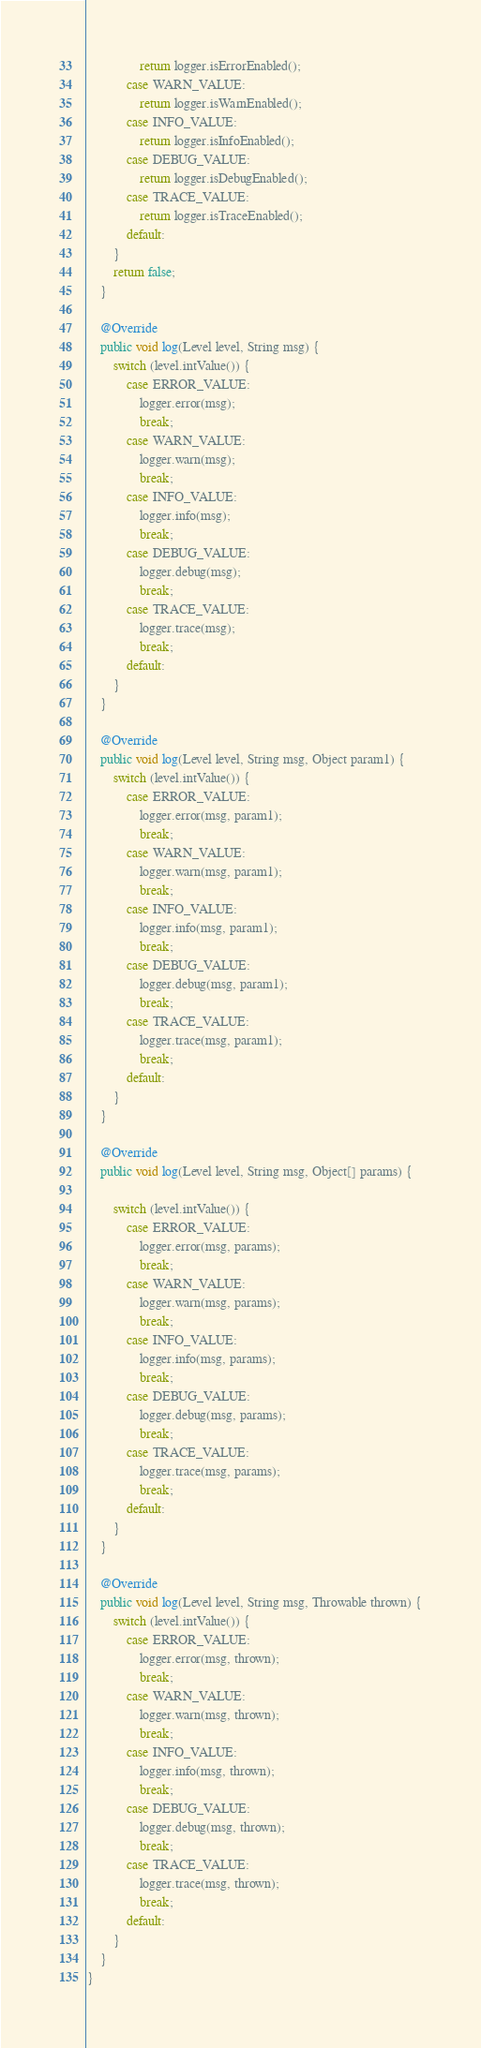<code> <loc_0><loc_0><loc_500><loc_500><_Java_>                return logger.isErrorEnabled();
            case WARN_VALUE:
                return logger.isWarnEnabled();
            case INFO_VALUE:
                return logger.isInfoEnabled();
            case DEBUG_VALUE:
                return logger.isDebugEnabled();
            case TRACE_VALUE:
                return logger.isTraceEnabled();
            default:
        }
        return false;
    }

    @Override
    public void log(Level level, String msg) {
        switch (level.intValue()) {
            case ERROR_VALUE:
                logger.error(msg);
                break;
            case WARN_VALUE:
                logger.warn(msg);
                break;
            case INFO_VALUE:
                logger.info(msg);
                break;
            case DEBUG_VALUE:
                logger.debug(msg);
                break;
            case TRACE_VALUE:
                logger.trace(msg);
                break;
            default:
        }
    }

    @Override
    public void log(Level level, String msg, Object param1) {
        switch (level.intValue()) {
            case ERROR_VALUE:
                logger.error(msg, param1);
                break;
            case WARN_VALUE:
                logger.warn(msg, param1);
                break;
            case INFO_VALUE:
                logger.info(msg, param1);
                break;
            case DEBUG_VALUE:
                logger.debug(msg, param1);
                break;
            case TRACE_VALUE:
                logger.trace(msg, param1);
                break;
            default:
        }
    }

    @Override
    public void log(Level level, String msg, Object[] params) {

        switch (level.intValue()) {
            case ERROR_VALUE:
                logger.error(msg, params);
                break;
            case WARN_VALUE:
                logger.warn(msg, params);
                break;
            case INFO_VALUE:
                logger.info(msg, params);
                break;
            case DEBUG_VALUE:
                logger.debug(msg, params);
                break;
            case TRACE_VALUE:
                logger.trace(msg, params);
                break;
            default:
        }
    }

    @Override
    public void log(Level level, String msg, Throwable thrown) {
        switch (level.intValue()) {
            case ERROR_VALUE:
                logger.error(msg, thrown);
                break;
            case WARN_VALUE:
                logger.warn(msg, thrown);
                break;
            case INFO_VALUE:
                logger.info(msg, thrown);
                break;
            case DEBUG_VALUE:
                logger.debug(msg, thrown);
                break;
            case TRACE_VALUE:
                logger.trace(msg, thrown);
                break;
            default:
        }
    }
}
</code> 